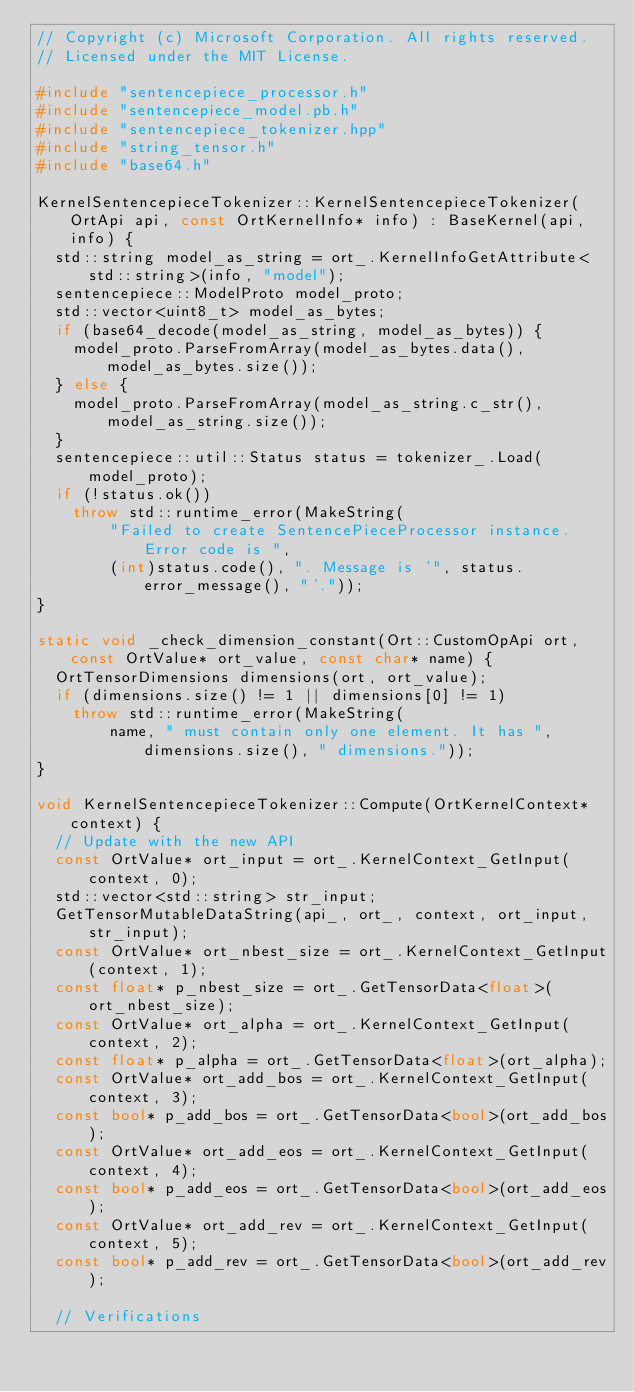<code> <loc_0><loc_0><loc_500><loc_500><_C++_>// Copyright (c) Microsoft Corporation. All rights reserved.
// Licensed under the MIT License.

#include "sentencepiece_processor.h"
#include "sentencepiece_model.pb.h"
#include "sentencepiece_tokenizer.hpp"
#include "string_tensor.h"
#include "base64.h"

KernelSentencepieceTokenizer::KernelSentencepieceTokenizer(OrtApi api, const OrtKernelInfo* info) : BaseKernel(api, info) {
  std::string model_as_string = ort_.KernelInfoGetAttribute<std::string>(info, "model");
  sentencepiece::ModelProto model_proto;
  std::vector<uint8_t> model_as_bytes;
  if (base64_decode(model_as_string, model_as_bytes)) {
    model_proto.ParseFromArray(model_as_bytes.data(), model_as_bytes.size());
  } else {
    model_proto.ParseFromArray(model_as_string.c_str(), model_as_string.size());
  }
  sentencepiece::util::Status status = tokenizer_.Load(model_proto);
  if (!status.ok())
    throw std::runtime_error(MakeString(
        "Failed to create SentencePieceProcessor instance. Error code is ",
        (int)status.code(), ". Message is '", status.error_message(), "'."));
}

static void _check_dimension_constant(Ort::CustomOpApi ort, const OrtValue* ort_value, const char* name) {
  OrtTensorDimensions dimensions(ort, ort_value);
  if (dimensions.size() != 1 || dimensions[0] != 1)
    throw std::runtime_error(MakeString(
        name, " must contain only one element. It has ", dimensions.size(), " dimensions."));
}

void KernelSentencepieceTokenizer::Compute(OrtKernelContext* context) {
  // Update with the new API
  const OrtValue* ort_input = ort_.KernelContext_GetInput(context, 0);
  std::vector<std::string> str_input;
  GetTensorMutableDataString(api_, ort_, context, ort_input, str_input);
  const OrtValue* ort_nbest_size = ort_.KernelContext_GetInput(context, 1);
  const float* p_nbest_size = ort_.GetTensorData<float>(ort_nbest_size);
  const OrtValue* ort_alpha = ort_.KernelContext_GetInput(context, 2);
  const float* p_alpha = ort_.GetTensorData<float>(ort_alpha);
  const OrtValue* ort_add_bos = ort_.KernelContext_GetInput(context, 3);
  const bool* p_add_bos = ort_.GetTensorData<bool>(ort_add_bos);
  const OrtValue* ort_add_eos = ort_.KernelContext_GetInput(context, 4);
  const bool* p_add_eos = ort_.GetTensorData<bool>(ort_add_eos);
  const OrtValue* ort_add_rev = ort_.KernelContext_GetInput(context, 5);
  const bool* p_add_rev = ort_.GetTensorData<bool>(ort_add_rev);

  // Verifications</code> 